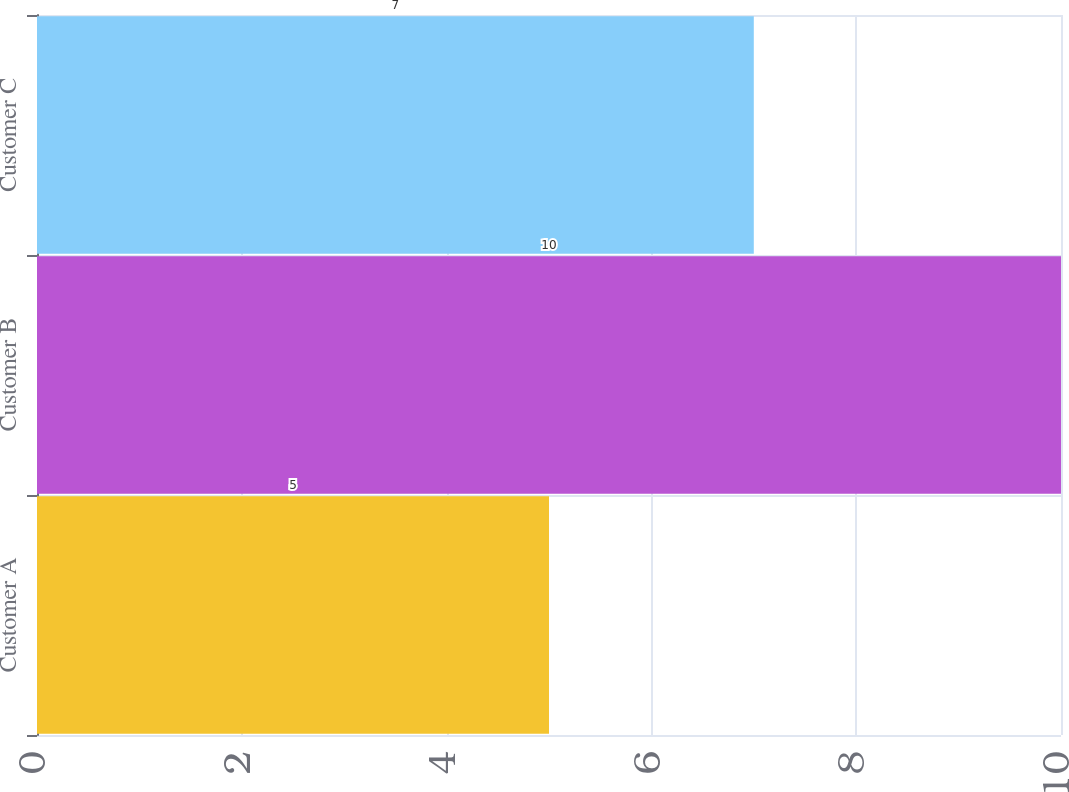<chart> <loc_0><loc_0><loc_500><loc_500><bar_chart><fcel>Customer A<fcel>Customer B<fcel>Customer C<nl><fcel>5<fcel>10<fcel>7<nl></chart> 